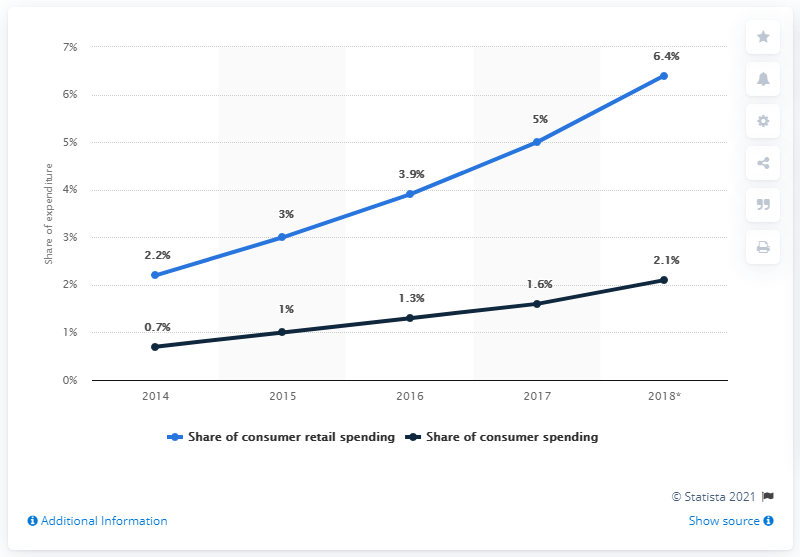List a handful of essential elements in this visual. In 2018, Amazon accounted for approximately 4.4% of total consumer spending in the United States. According to a survey conducted in 2018, Amazon accounted for approximately 6.4% of the total consumer retail spending in the United States. 